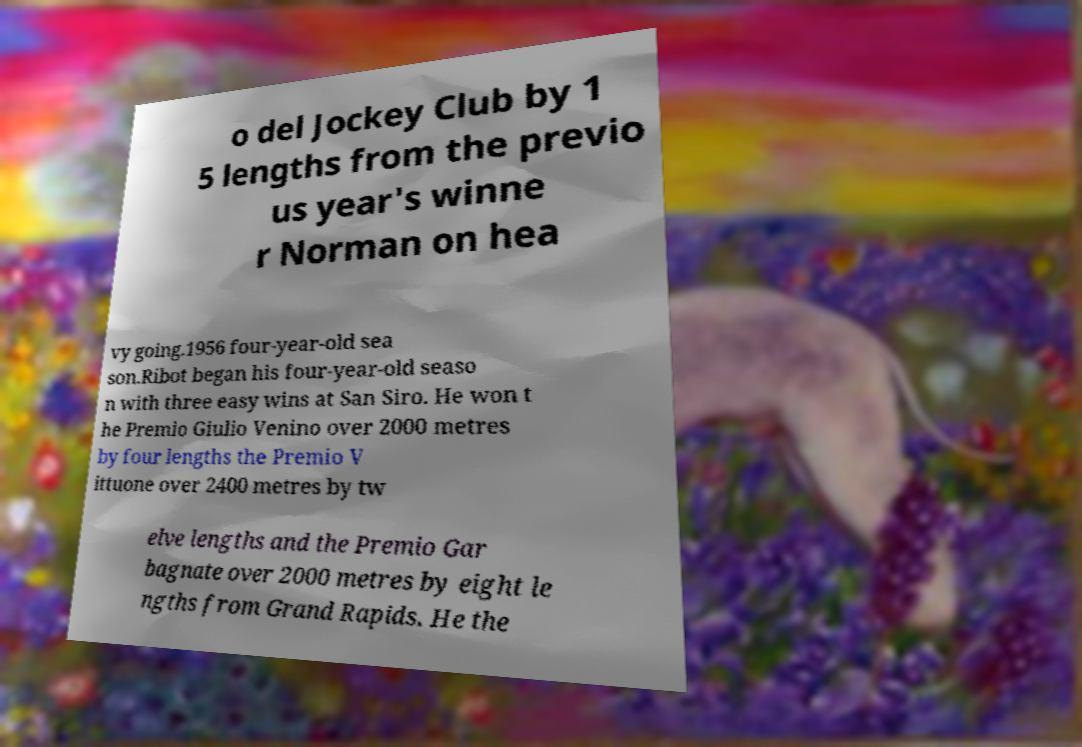Can you read and provide the text displayed in the image?This photo seems to have some interesting text. Can you extract and type it out for me? o del Jockey Club by 1 5 lengths from the previo us year's winne r Norman on hea vy going.1956 four-year-old sea son.Ribot began his four-year-old seaso n with three easy wins at San Siro. He won t he Premio Giulio Venino over 2000 metres by four lengths the Premio V ittuone over 2400 metres by tw elve lengths and the Premio Gar bagnate over 2000 metres by eight le ngths from Grand Rapids. He the 